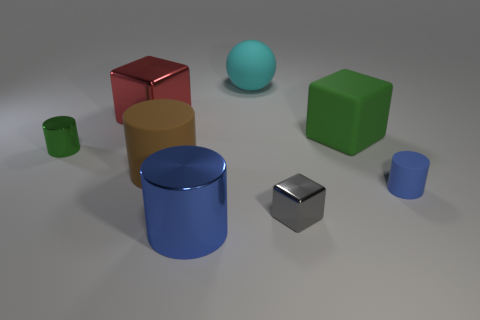Add 2 gray shiny blocks. How many objects exist? 10 Subtract all cubes. How many objects are left? 5 Add 5 big cyan cubes. How many big cyan cubes exist? 5 Subtract 0 brown blocks. How many objects are left? 8 Subtract all cyan cylinders. Subtract all red objects. How many objects are left? 7 Add 3 blue objects. How many blue objects are left? 5 